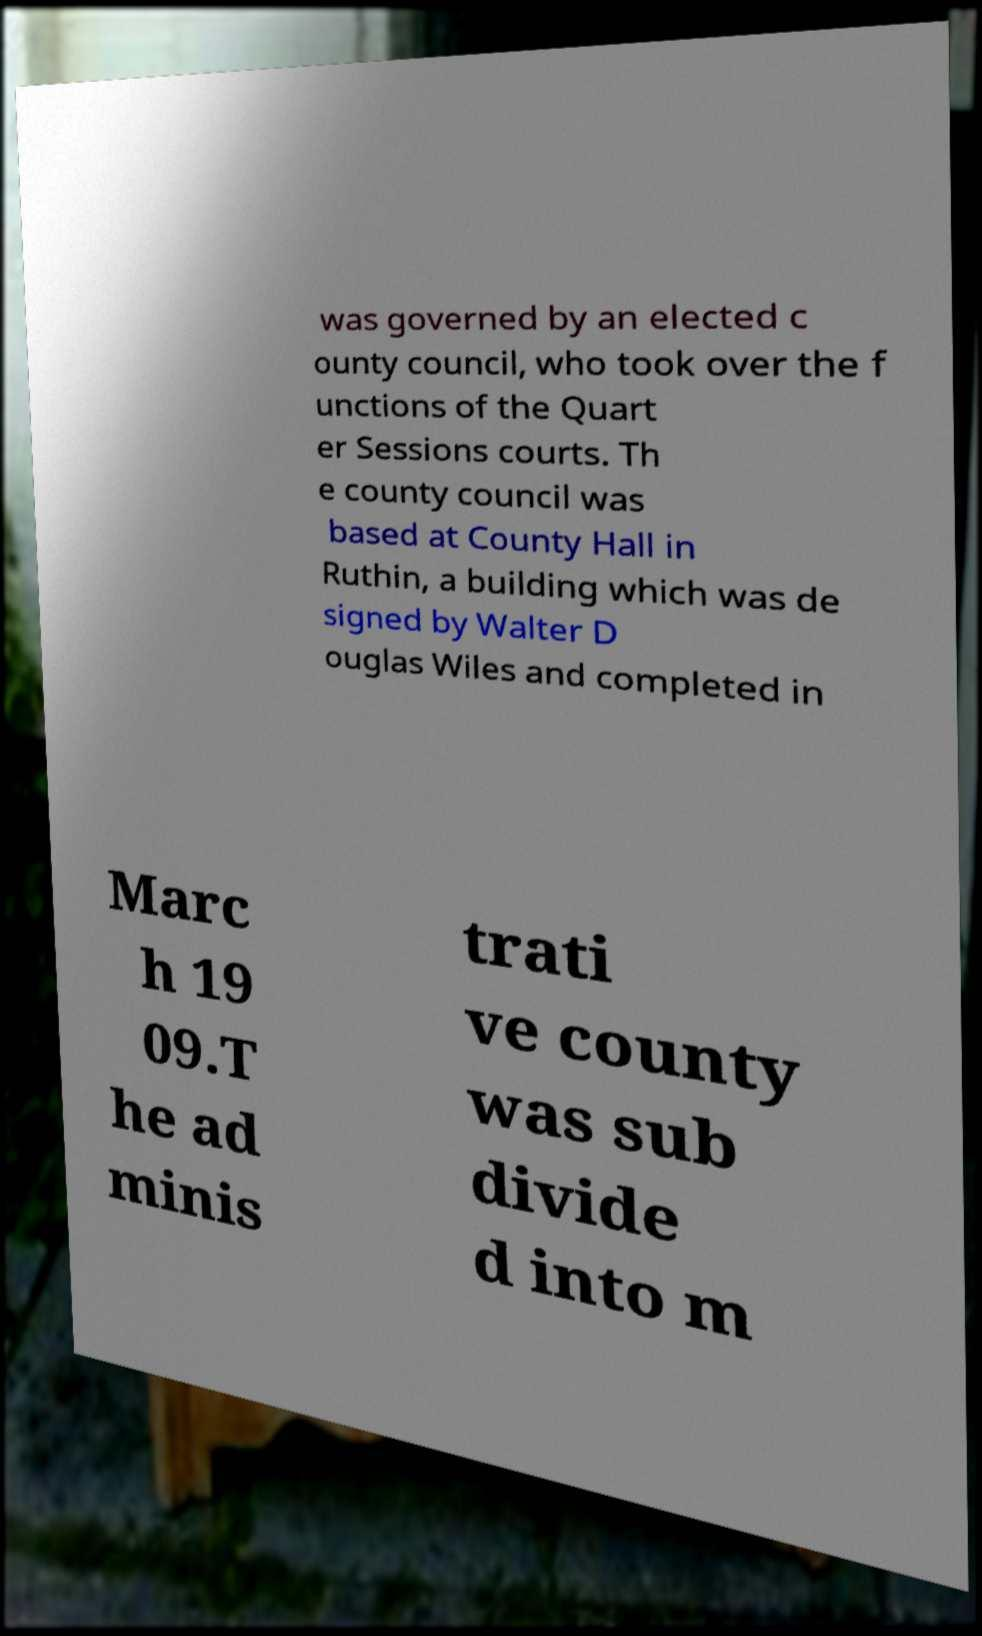Could you extract and type out the text from this image? was governed by an elected c ounty council, who took over the f unctions of the Quart er Sessions courts. Th e county council was based at County Hall in Ruthin, a building which was de signed by Walter D ouglas Wiles and completed in Marc h 19 09.T he ad minis trati ve county was sub divide d into m 